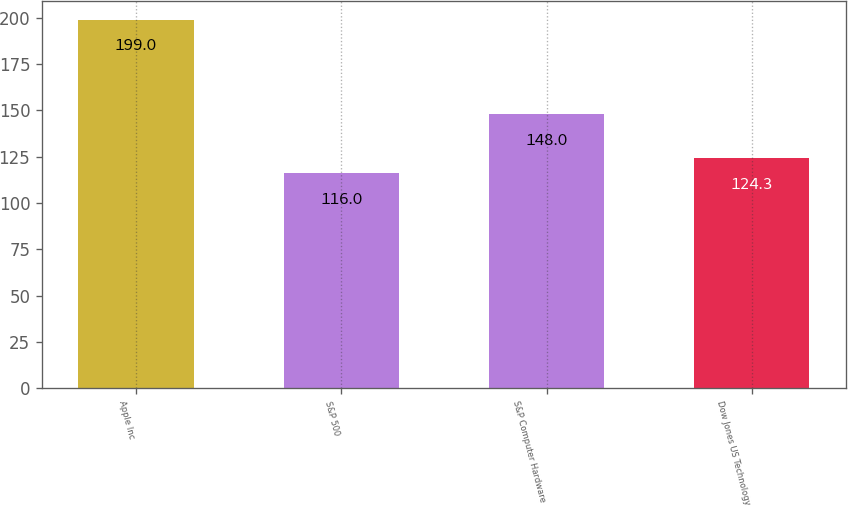Convert chart to OTSL. <chart><loc_0><loc_0><loc_500><loc_500><bar_chart><fcel>Apple Inc<fcel>S&P 500<fcel>S&P Computer Hardware<fcel>Dow Jones US Technology<nl><fcel>199<fcel>116<fcel>148<fcel>124.3<nl></chart> 